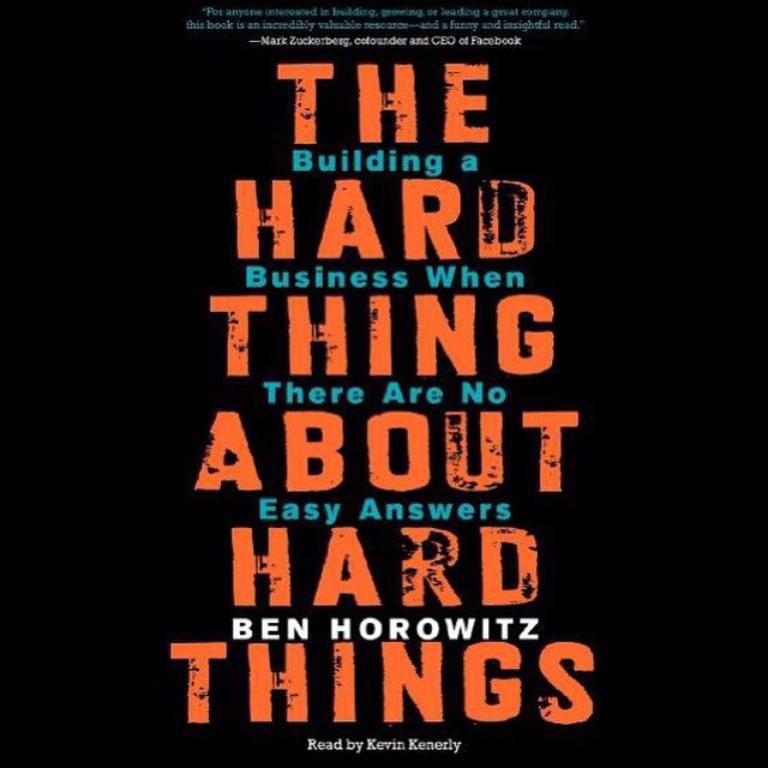<image>
Relay a brief, clear account of the picture shown. poster for an audio book called The Hard Thing About Hard Things: building a business when there are no easy answers 